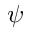Convert formula to latex. <formula><loc_0><loc_0><loc_500><loc_500>\psi</formula> 